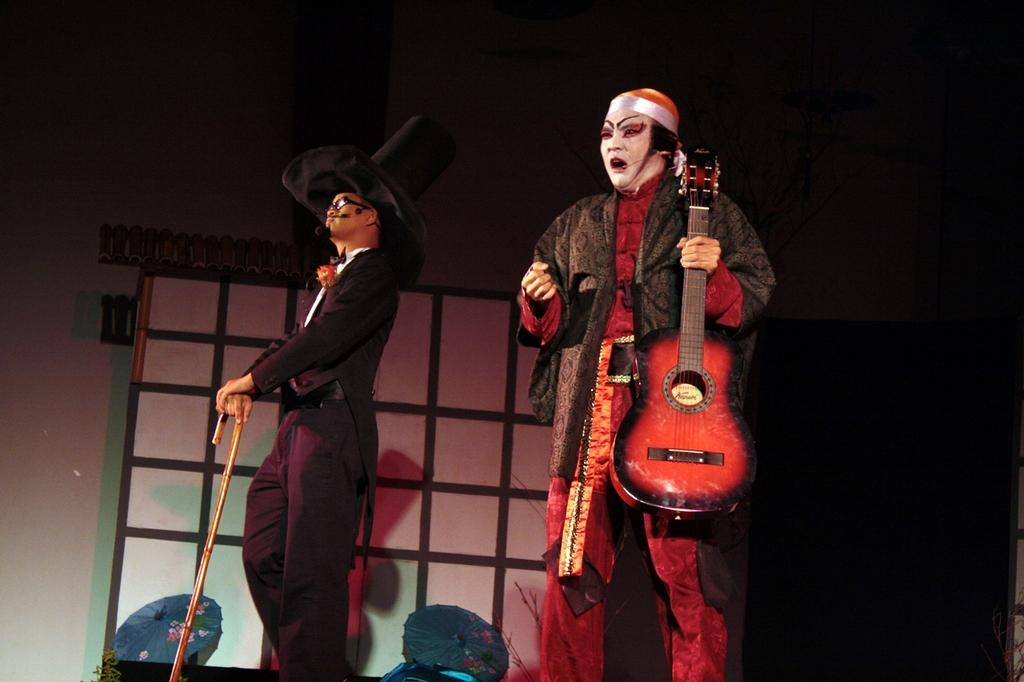What is the person in the red dress holding in the image? The person in the red dress is holding a guitar. What is the person in the black dress holding in the image? The person in the black dress is holding a stick. Can you describe the clothing of the person in the red dress? The person in the red dress is wearing a red dress. Can you describe the clothing of the person in the black dress? The person in the black dress is wearing a black dress. What type of grape can be seen on the person's head in the image? There are no grapes present in the image; both people are wearing dresses and holding other objects. What type of base is supporting the person in the red dress in the image? There is no base supporting the person in the red dress in the image; they are standing on the ground. 